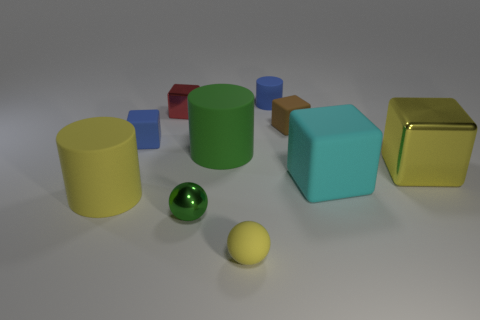Subtract all green spheres. How many spheres are left? 1 Subtract all tiny metallic cubes. How many cubes are left? 4 Subtract all cylinders. How many objects are left? 7 Subtract 2 cylinders. How many cylinders are left? 1 Subtract all purple balls. Subtract all red cubes. How many balls are left? 2 Subtract all cyan blocks. How many brown balls are left? 0 Subtract all purple metallic things. Subtract all small matte objects. How many objects are left? 6 Add 9 small green objects. How many small green objects are left? 10 Add 9 cyan rubber objects. How many cyan rubber objects exist? 10 Subtract 0 gray cylinders. How many objects are left? 10 